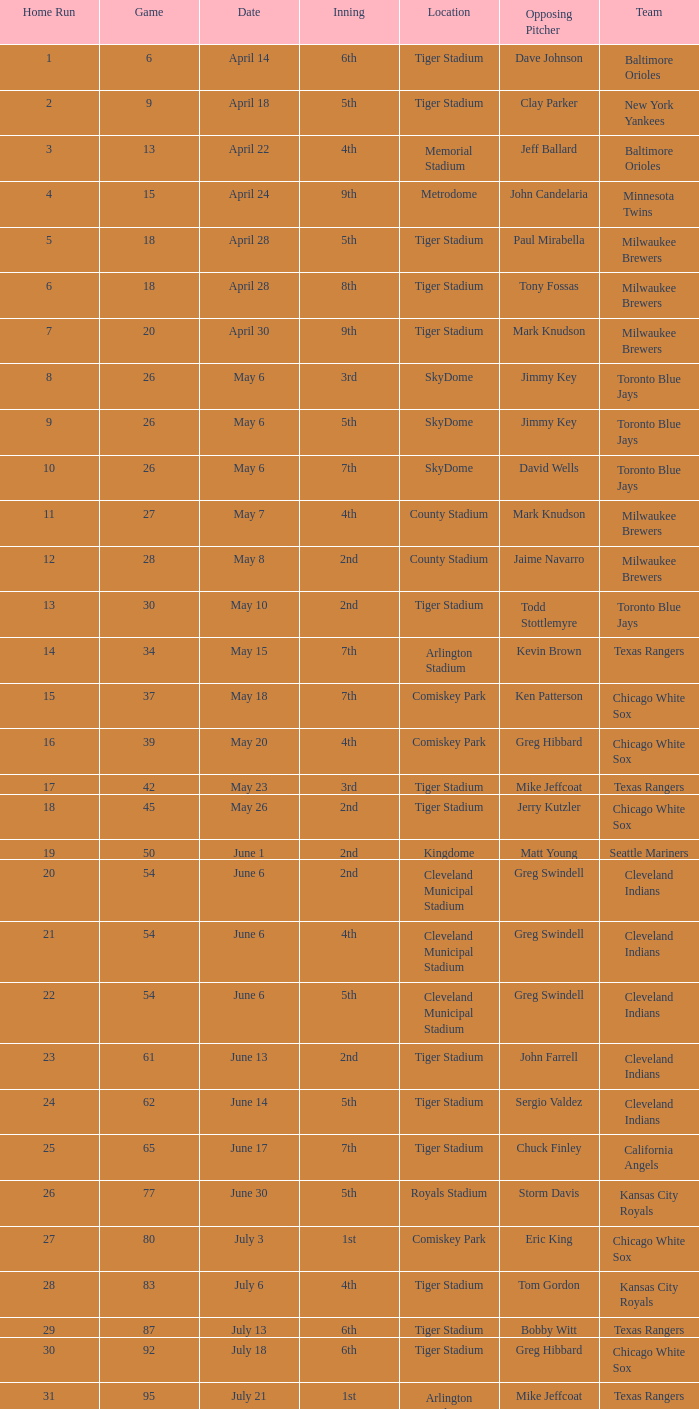On june 17 in tiger stadium, what was the typical home run? 25.0. 